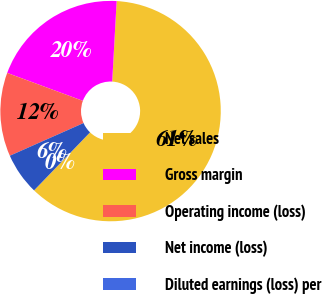Convert chart to OTSL. <chart><loc_0><loc_0><loc_500><loc_500><pie_chart><fcel>Net sales<fcel>Gross margin<fcel>Operating income (loss)<fcel>Net income (loss)<fcel>Diluted earnings (loss) per<nl><fcel>61.33%<fcel>20.25%<fcel>12.27%<fcel>6.14%<fcel>0.01%<nl></chart> 